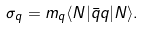Convert formula to latex. <formula><loc_0><loc_0><loc_500><loc_500>\sigma _ { q } = m _ { q } \langle N | \bar { q } q | N \rangle .</formula> 